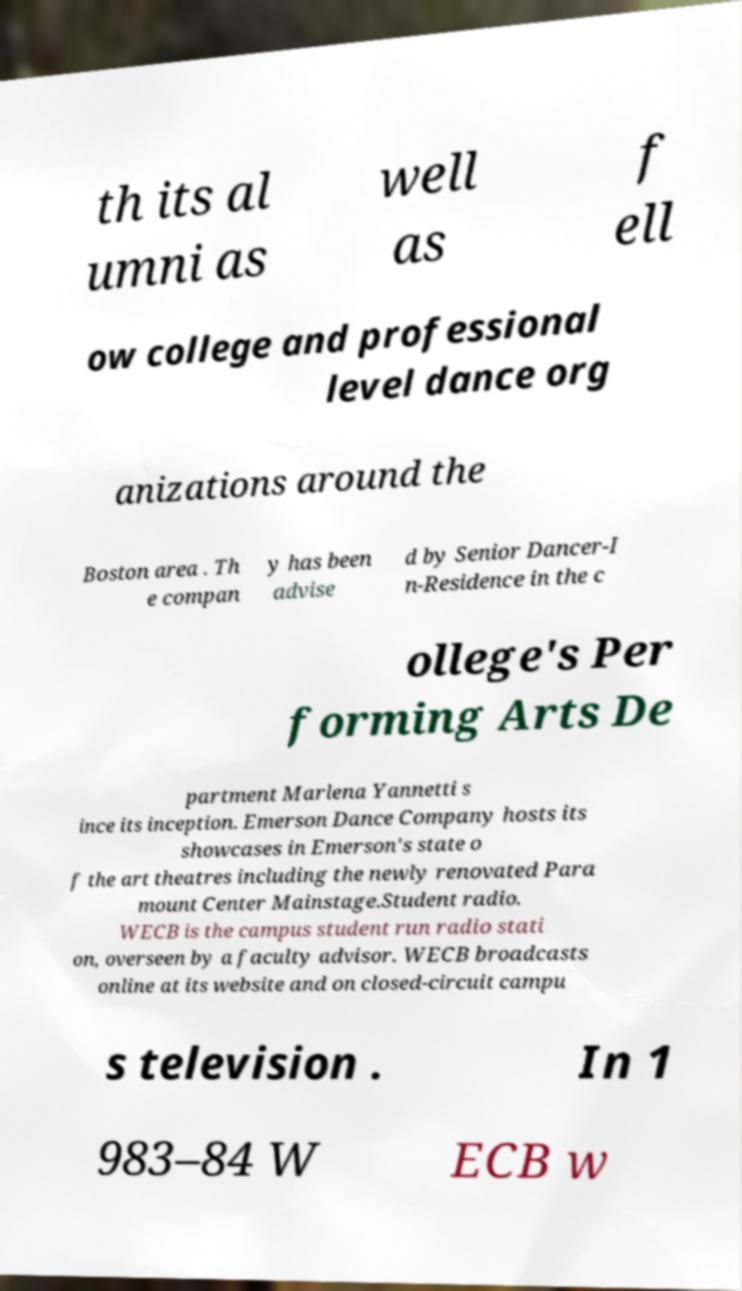There's text embedded in this image that I need extracted. Can you transcribe it verbatim? th its al umni as well as f ell ow college and professional level dance org anizations around the Boston area . Th e compan y has been advise d by Senior Dancer-I n-Residence in the c ollege's Per forming Arts De partment Marlena Yannetti s ince its inception. Emerson Dance Company hosts its showcases in Emerson's state o f the art theatres including the newly renovated Para mount Center Mainstage.Student radio. WECB is the campus student run radio stati on, overseen by a faculty advisor. WECB broadcasts online at its website and on closed-circuit campu s television . In 1 983–84 W ECB w 